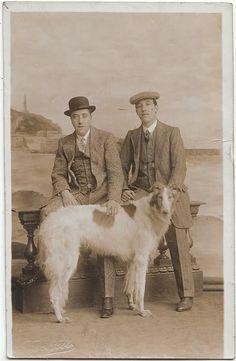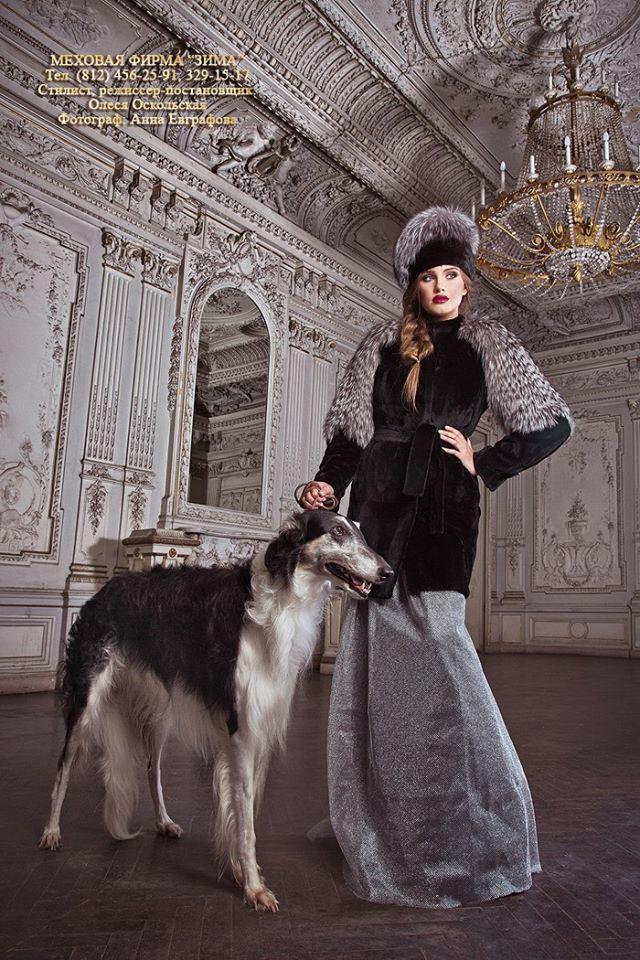The first image is the image on the left, the second image is the image on the right. Considering the images on both sides, is "The left image shows a woman in black standing behind one white hound." valid? Answer yes or no. No. The first image is the image on the left, the second image is the image on the right. Examine the images to the left and right. Is the description "In one image, a woman wearing a long dark dress with long sleeves is posed for a studio portrait with her hand on the head of a large white dog." accurate? Answer yes or no. No. 